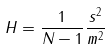<formula> <loc_0><loc_0><loc_500><loc_500>H = \frac { 1 } { N - 1 } \frac { s ^ { 2 } } { m ^ { 2 } }</formula> 